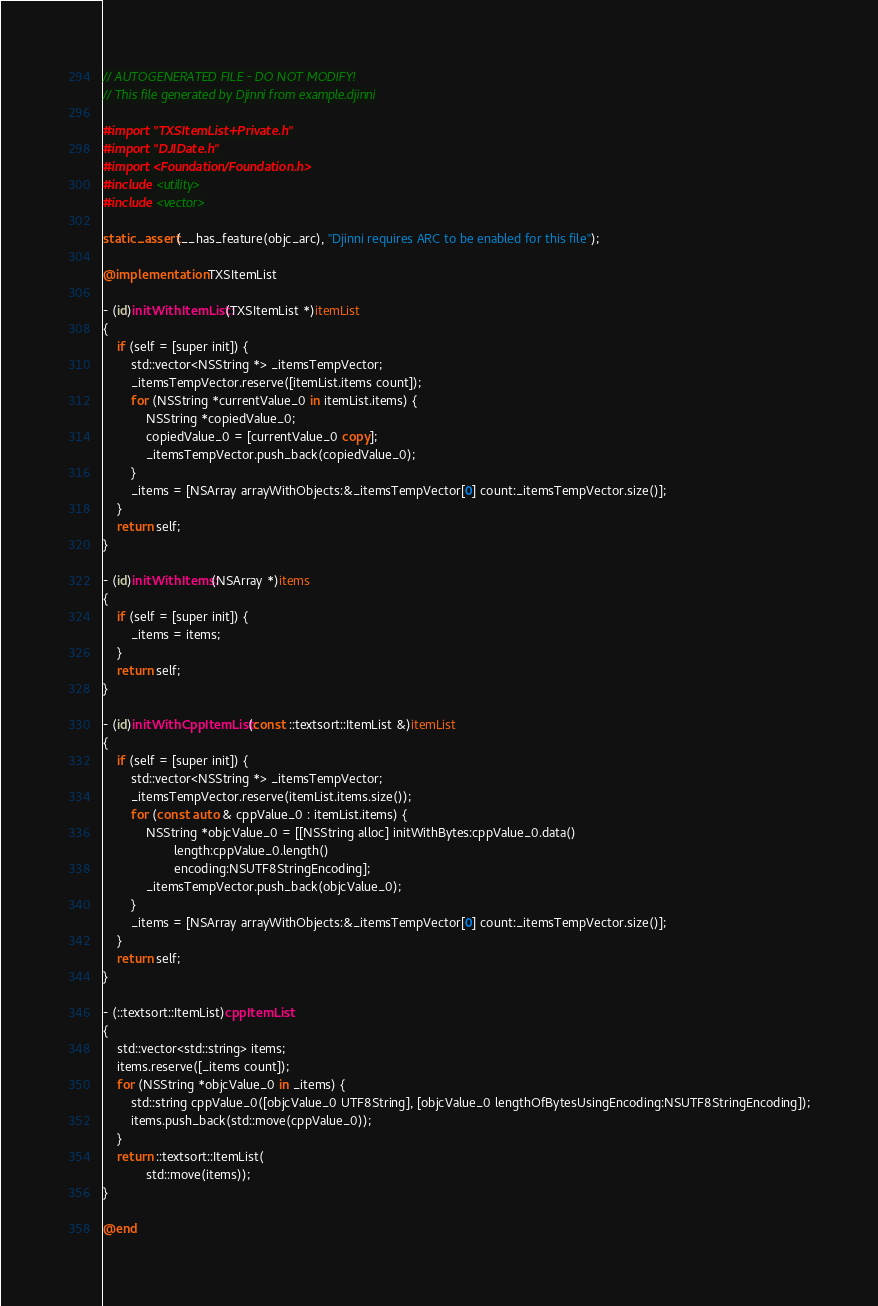Convert code to text. <code><loc_0><loc_0><loc_500><loc_500><_ObjectiveC_>// AUTOGENERATED FILE - DO NOT MODIFY!
// This file generated by Djinni from example.djinni

#import "TXSItemList+Private.h"
#import "DJIDate.h"
#import <Foundation/Foundation.h>
#include <utility>
#include <vector>

static_assert(__has_feature(objc_arc), "Djinni requires ARC to be enabled for this file");

@implementation TXSItemList

- (id)initWithItemList:(TXSItemList *)itemList
{
    if (self = [super init]) {
        std::vector<NSString *> _itemsTempVector;
        _itemsTempVector.reserve([itemList.items count]);
        for (NSString *currentValue_0 in itemList.items) {
            NSString *copiedValue_0;
            copiedValue_0 = [currentValue_0 copy];
            _itemsTempVector.push_back(copiedValue_0);
        }
        _items = [NSArray arrayWithObjects:&_itemsTempVector[0] count:_itemsTempVector.size()];
    }
    return self;
}

- (id)initWithItems:(NSArray *)items
{
    if (self = [super init]) {
        _items = items;
    }
    return self;
}

- (id)initWithCppItemList:(const ::textsort::ItemList &)itemList
{
    if (self = [super init]) {
        std::vector<NSString *> _itemsTempVector;
        _itemsTempVector.reserve(itemList.items.size());
        for (const auto & cppValue_0 : itemList.items) {
            NSString *objcValue_0 = [[NSString alloc] initWithBytes:cppValue_0.data()
                    length:cppValue_0.length()
                    encoding:NSUTF8StringEncoding];
            _itemsTempVector.push_back(objcValue_0);
        }
        _items = [NSArray arrayWithObjects:&_itemsTempVector[0] count:_itemsTempVector.size()];
    }
    return self;
}

- (::textsort::ItemList)cppItemList
{
    std::vector<std::string> items;
    items.reserve([_items count]);
    for (NSString *objcValue_0 in _items) {
        std::string cppValue_0([objcValue_0 UTF8String], [objcValue_0 lengthOfBytesUsingEncoding:NSUTF8StringEncoding]);
        items.push_back(std::move(cppValue_0));
    }
    return ::textsort::ItemList(
            std::move(items));
}

@end
</code> 